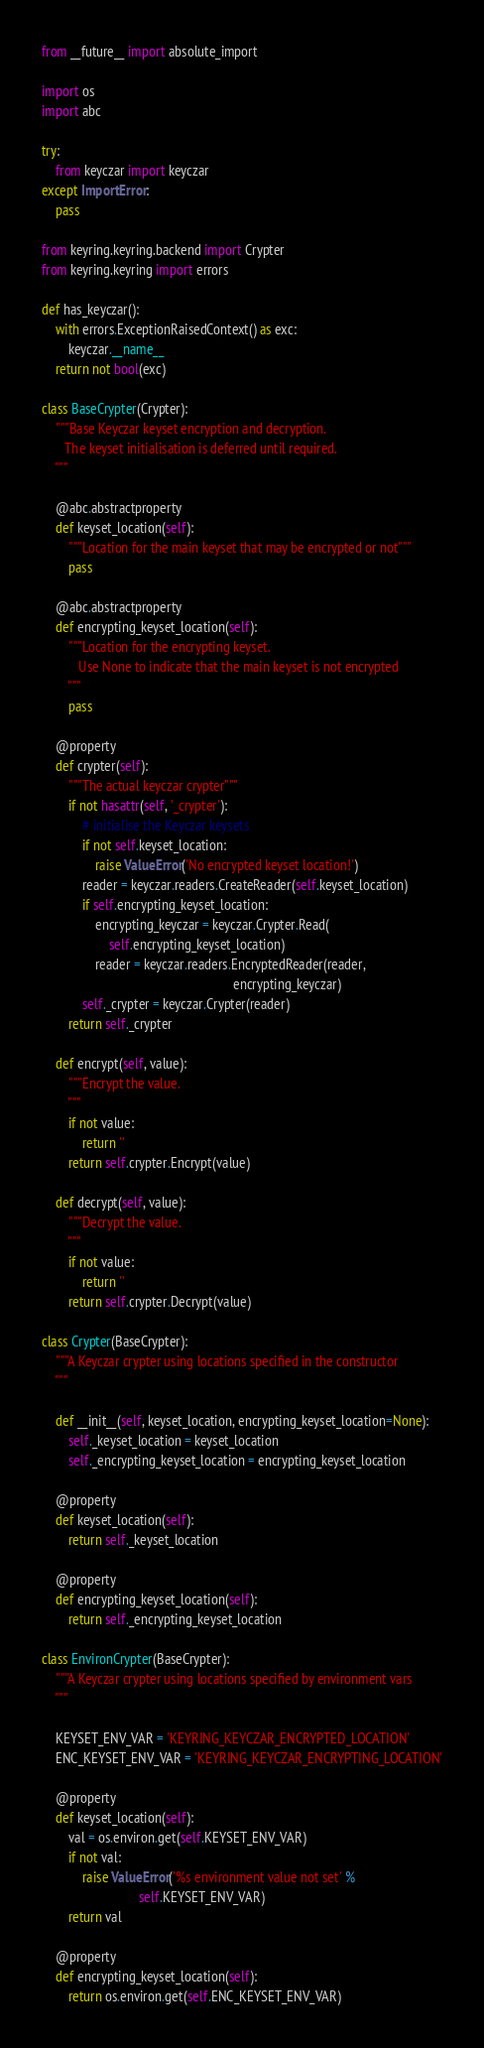Convert code to text. <code><loc_0><loc_0><loc_500><loc_500><_Python_>from __future__ import absolute_import

import os
import abc

try:
    from keyczar import keyczar
except ImportError:
    pass

from keyring.keyring.backend import Crypter
from keyring.keyring import errors

def has_keyczar():
    with errors.ExceptionRaisedContext() as exc:
        keyczar.__name__
    return not bool(exc)

class BaseCrypter(Crypter):
    """Base Keyczar keyset encryption and decryption.
       The keyset initialisation is deferred until required.
    """

    @abc.abstractproperty
    def keyset_location(self):
        """Location for the main keyset that may be encrypted or not"""
        pass

    @abc.abstractproperty
    def encrypting_keyset_location(self):
        """Location for the encrypting keyset.
           Use None to indicate that the main keyset is not encrypted
        """
        pass

    @property
    def crypter(self):
        """The actual keyczar crypter"""
        if not hasattr(self, '_crypter'):
            # initialise the Keyczar keysets
            if not self.keyset_location:
                raise ValueError('No encrypted keyset location!')
            reader = keyczar.readers.CreateReader(self.keyset_location)
            if self.encrypting_keyset_location:
                encrypting_keyczar = keyczar.Crypter.Read(
                    self.encrypting_keyset_location)
                reader = keyczar.readers.EncryptedReader(reader,
                                                         encrypting_keyczar)
            self._crypter = keyczar.Crypter(reader)
        return self._crypter

    def encrypt(self, value):
        """Encrypt the value.
        """
        if not value:
            return ''
        return self.crypter.Encrypt(value)

    def decrypt(self, value):
        """Decrypt the value.
        """
        if not value:
            return ''
        return self.crypter.Decrypt(value)

class Crypter(BaseCrypter):
    """A Keyczar crypter using locations specified in the constructor
    """

    def __init__(self, keyset_location, encrypting_keyset_location=None):
        self._keyset_location = keyset_location
        self._encrypting_keyset_location = encrypting_keyset_location

    @property
    def keyset_location(self):
        return self._keyset_location

    @property
    def encrypting_keyset_location(self):
        return self._encrypting_keyset_location

class EnvironCrypter(BaseCrypter):
    """A Keyczar crypter using locations specified by environment vars
    """

    KEYSET_ENV_VAR = 'KEYRING_KEYCZAR_ENCRYPTED_LOCATION'
    ENC_KEYSET_ENV_VAR = 'KEYRING_KEYCZAR_ENCRYPTING_LOCATION'

    @property
    def keyset_location(self):
        val = os.environ.get(self.KEYSET_ENV_VAR)
        if not val:
            raise ValueError('%s environment value not set' %
                             self.KEYSET_ENV_VAR)
        return val

    @property
    def encrypting_keyset_location(self):
        return os.environ.get(self.ENC_KEYSET_ENV_VAR)
</code> 